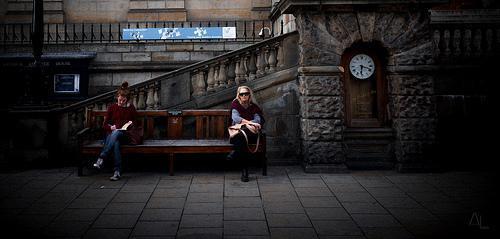How many people are sitting on the bench?
Give a very brief answer. 2. 